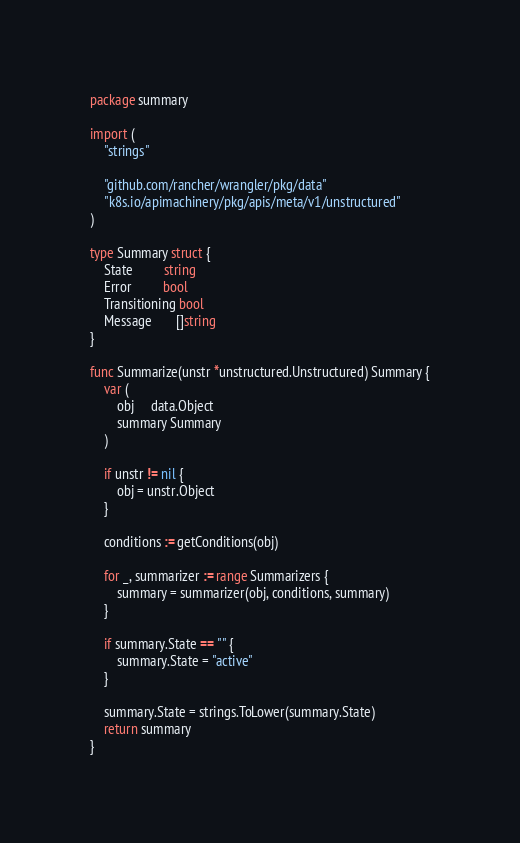<code> <loc_0><loc_0><loc_500><loc_500><_Go_>package summary

import (
	"strings"

	"github.com/rancher/wrangler/pkg/data"
	"k8s.io/apimachinery/pkg/apis/meta/v1/unstructured"
)

type Summary struct {
	State         string
	Error         bool
	Transitioning bool
	Message       []string
}

func Summarize(unstr *unstructured.Unstructured) Summary {
	var (
		obj     data.Object
		summary Summary
	)

	if unstr != nil {
		obj = unstr.Object
	}

	conditions := getConditions(obj)

	for _, summarizer := range Summarizers {
		summary = summarizer(obj, conditions, summary)
	}

	if summary.State == "" {
		summary.State = "active"
	}

	summary.State = strings.ToLower(summary.State)
	return summary
}
</code> 